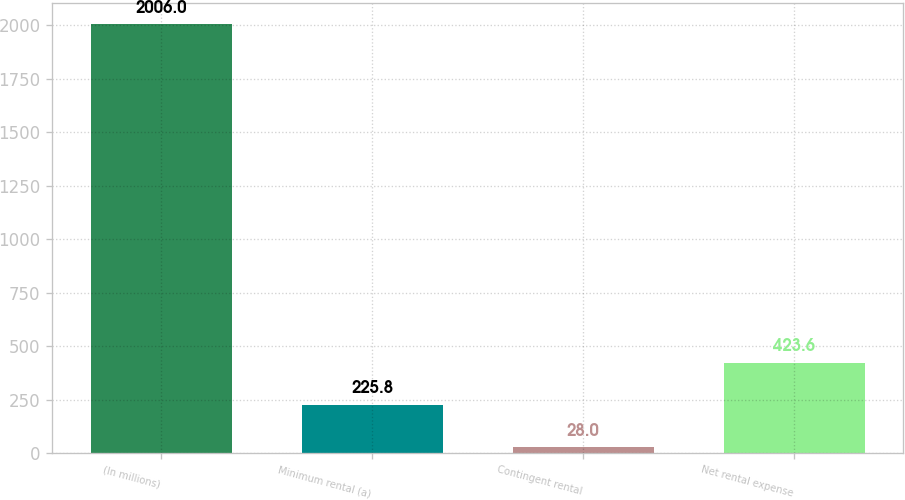<chart> <loc_0><loc_0><loc_500><loc_500><bar_chart><fcel>(In millions)<fcel>Minimum rental (a)<fcel>Contingent rental<fcel>Net rental expense<nl><fcel>2006<fcel>225.8<fcel>28<fcel>423.6<nl></chart> 